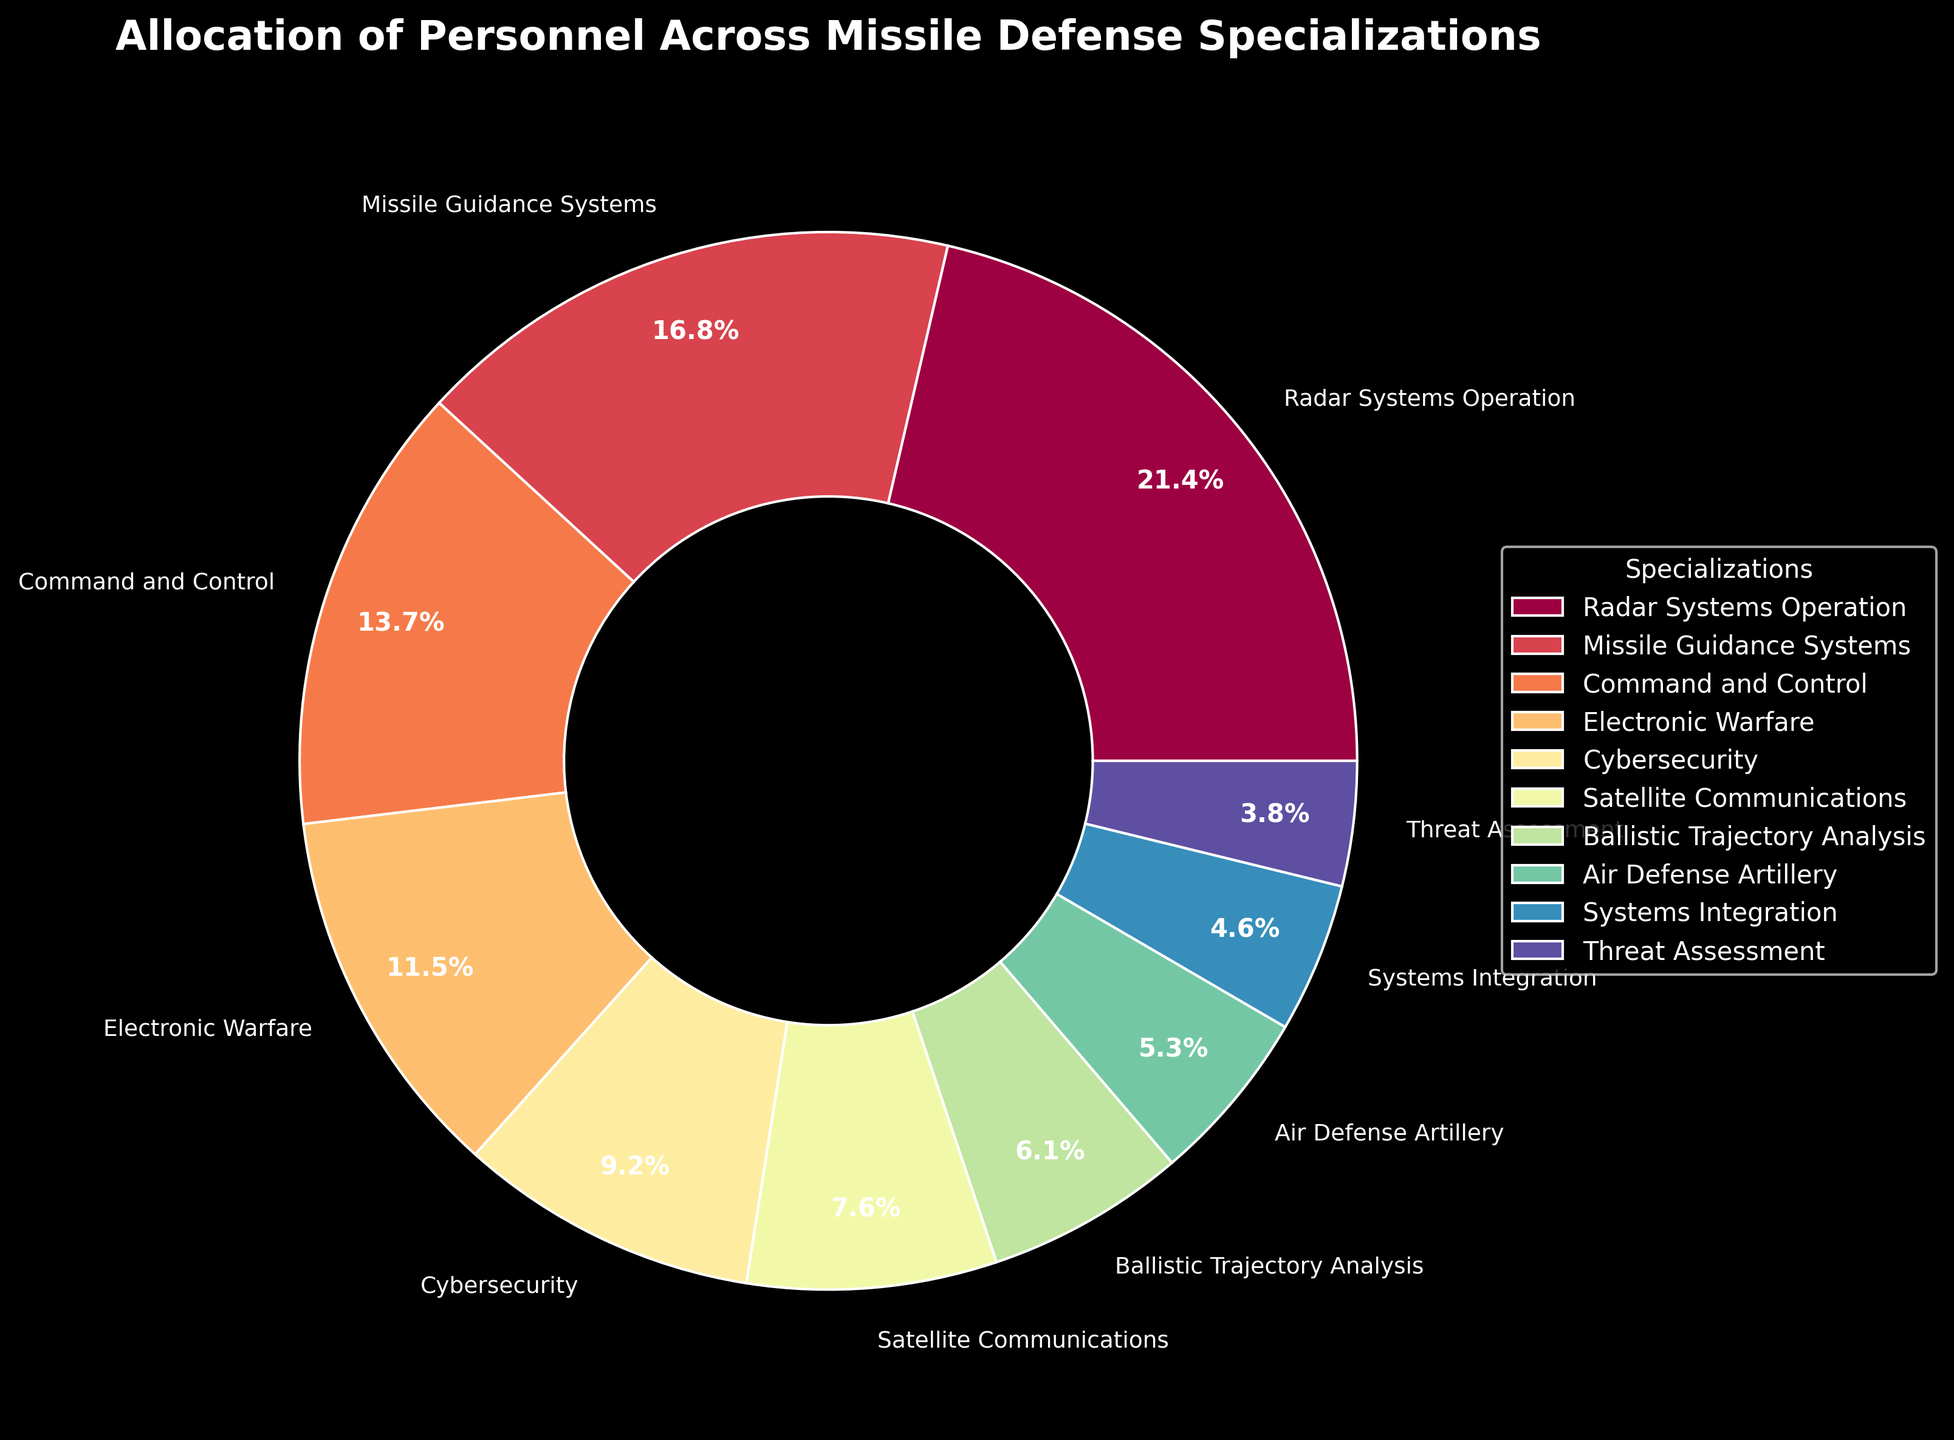What's the largest specialization by personnel, and what percentage of the total does it represent? The largest specialization is identified by the largest slice in the pie chart. Look for the slice labeled "Radar Systems Operation" and check the percentage it represents.
Answer: Radar Systems Operation, 22.4% Which two specializations have the closest number of personnel? Compare the slice sizes and their labels to determine which two specializations have the closest numeric values. "Cybersecurity" and "Satellite Communications" both have percentages close to each other, with 12 and 10 personnel respectively.
Answer: Cybersecurity and Satellite Communications How many more personnel does the Missile Guidance Systems specialization have than Air Defense Artillery? Find the slices for "Missile Guidance Systems" and "Air Defense Artillery." The difference in their personnel numbers is calculated as 22 - 7.
Answer: 15 Which specialization has the second smallest personnel allocation? Identify the specialization with the second smallest slice after "Threat Assessment," which is "Systems Integration" with 6 personnel.
Answer: Systems Integration What's the total percentage of personnel allocated to Electronic Warfare and Cybersecurity combined? Sum the percentages of the slices labeled "Electronic Warfare" and "Cybersecurity." These are 15 and 12 personnel respectively. Their percentages are calculated as (15 / 131 * 100) + (12 / 131 * 100).
Answer: 20.6% How does personnel allocation to Command and Control compare to Ballistic Trajectory Analysis? Find the slices for both specializations and compare their personnel values. "Command and Control" has 18 personnel, while "Ballistic Trajectory Analysis" has 8 personnel.
Answer: Command and Control has 10 more personnel than Ballistic Trajectory Analysis Which specialization occupies a larger portion of the pie chart: Satellite Communications or Threat Assessment? Look at the slices for "Satellite Communications" and "Threat Assessment," and compare their sizes. "Satellite Communications" has 10 personnel while "Threat Assessment" has 5.
Answer: Satellite Communications What percentage of the personnel does the top three specializations (Radar Systems Operation, Missile Guidance Systems, and Command and Control) add up to? Sum the percentages of the slices labeled "Radar Systems Operation," "Missile Guidance Systems," and "Command and Control." Their personnel numbers are 28, 22, and 18 respectively. The combined percentage is calculated as (28 / 131 * 100) + (22 / 131 * 100) + (18 / 131 * 100).
Answer: 52.7% What specialization comes immediately after Electronic Warfare in terms of personnel numbers? Identify the slice for "Electronic Warfare" and find the next largest slice. "Cybersecurity" with 12 personnel comes immediately after "Electronic Warfare" with 15 personnel.
Answer: Cybersecurity 